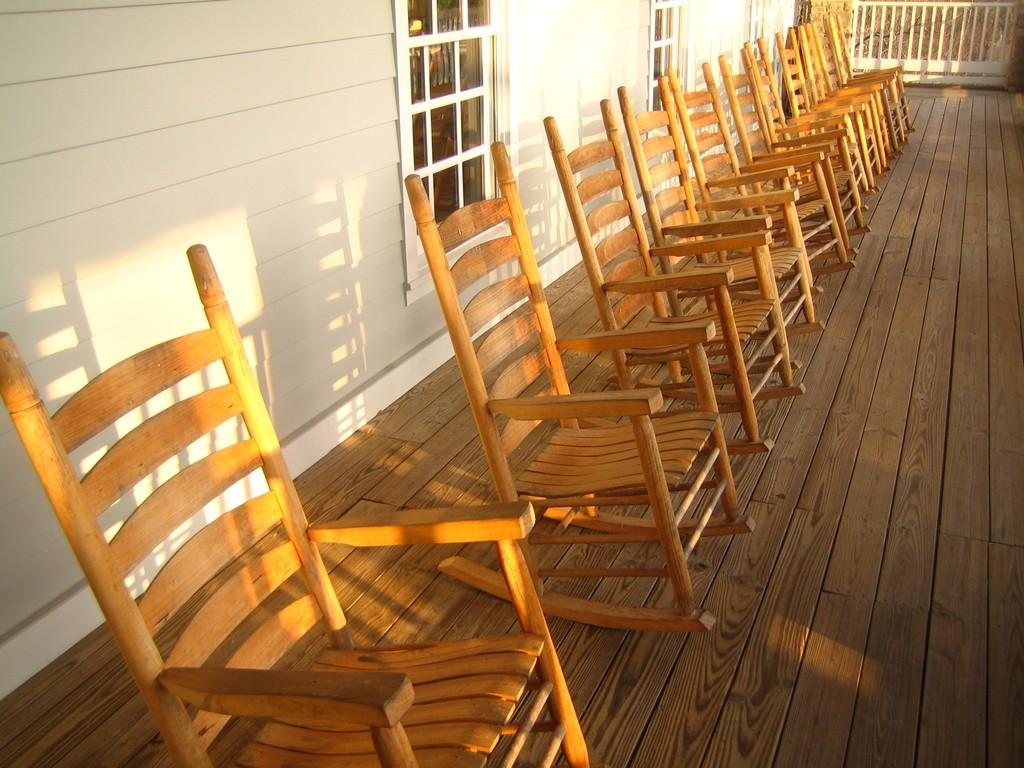What type of furniture is on the platform in the image? There are chairs on a platform in the image. What is the background of the image? There is a wall visible in the image. What type of barrier is present in the image? There is a fence in the image. What allows light and air into the space in the image? There are windows in the image. What type of plough is being used to make a discovery in the image? There is no plough or discovery present in the image. How many drops of water can be seen falling from the windows in the image? There is no mention of water or drops in the image; it only features chairs, a platform, a wall, a fence, and windows. 